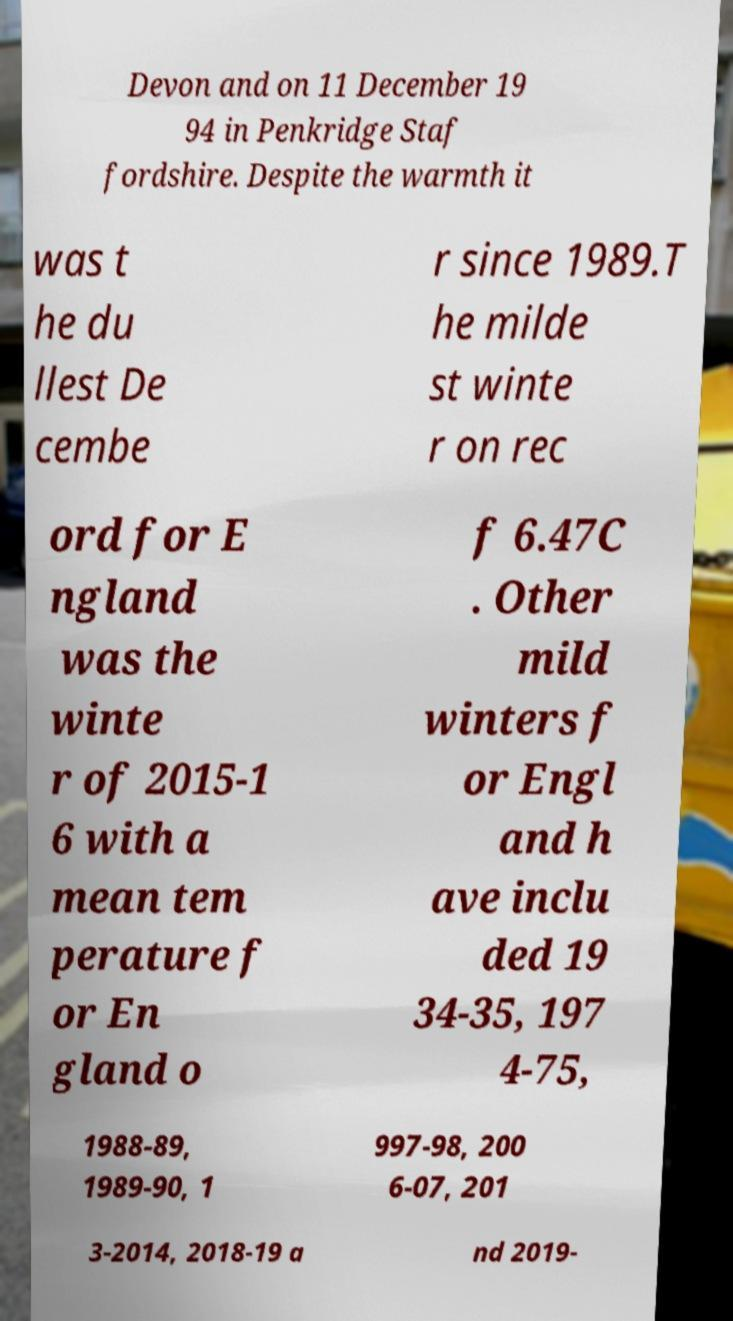Please identify and transcribe the text found in this image. Devon and on 11 December 19 94 in Penkridge Staf fordshire. Despite the warmth it was t he du llest De cembe r since 1989.T he milde st winte r on rec ord for E ngland was the winte r of 2015-1 6 with a mean tem perature f or En gland o f 6.47C . Other mild winters f or Engl and h ave inclu ded 19 34-35, 197 4-75, 1988-89, 1989-90, 1 997-98, 200 6-07, 201 3-2014, 2018-19 a nd 2019- 